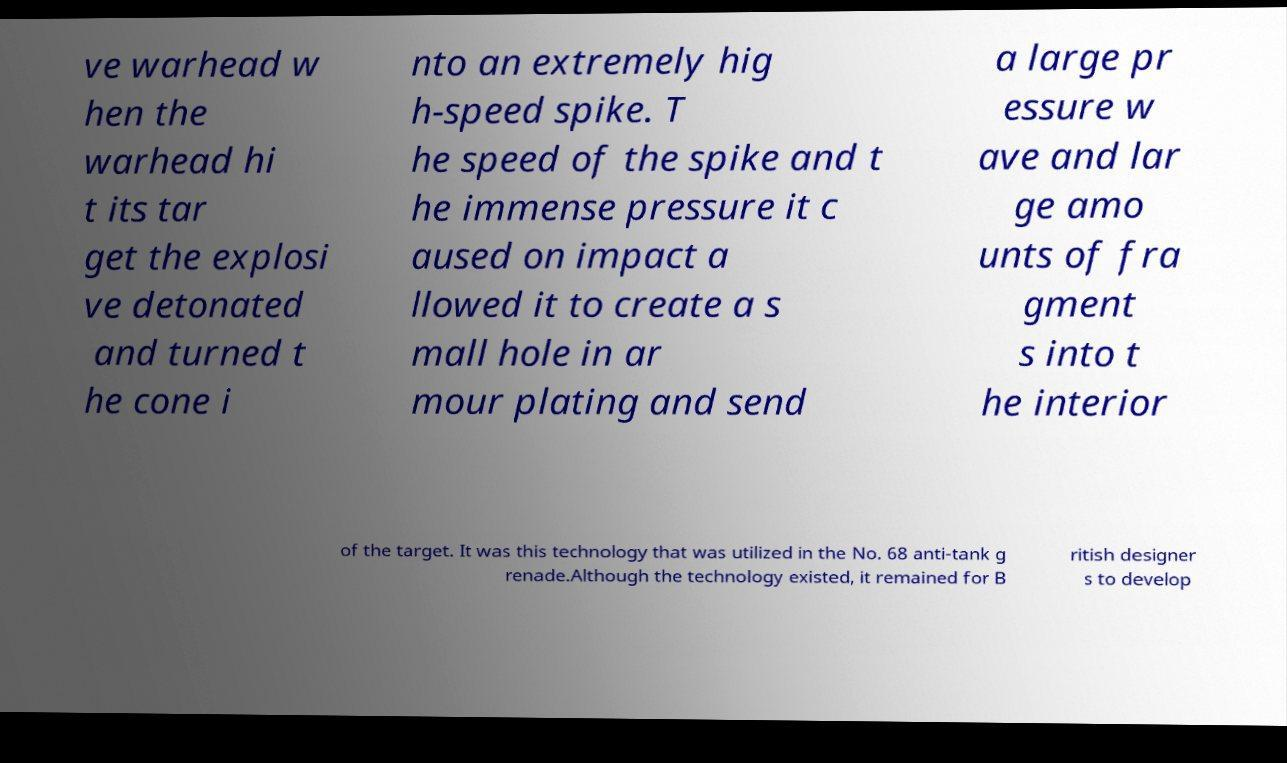What messages or text are displayed in this image? I need them in a readable, typed format. ve warhead w hen the warhead hi t its tar get the explosi ve detonated and turned t he cone i nto an extremely hig h-speed spike. T he speed of the spike and t he immense pressure it c aused on impact a llowed it to create a s mall hole in ar mour plating and send a large pr essure w ave and lar ge amo unts of fra gment s into t he interior of the target. It was this technology that was utilized in the No. 68 anti-tank g renade.Although the technology existed, it remained for B ritish designer s to develop 